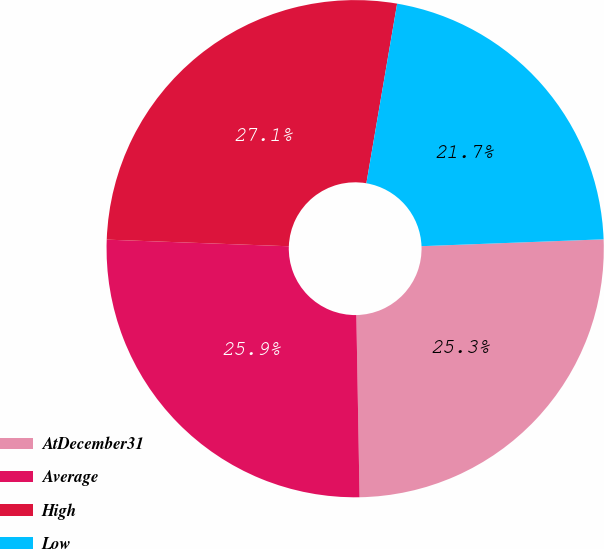<chart> <loc_0><loc_0><loc_500><loc_500><pie_chart><fcel>AtDecember31<fcel>Average<fcel>High<fcel>Low<nl><fcel>25.32%<fcel>25.86%<fcel>27.12%<fcel>21.7%<nl></chart> 